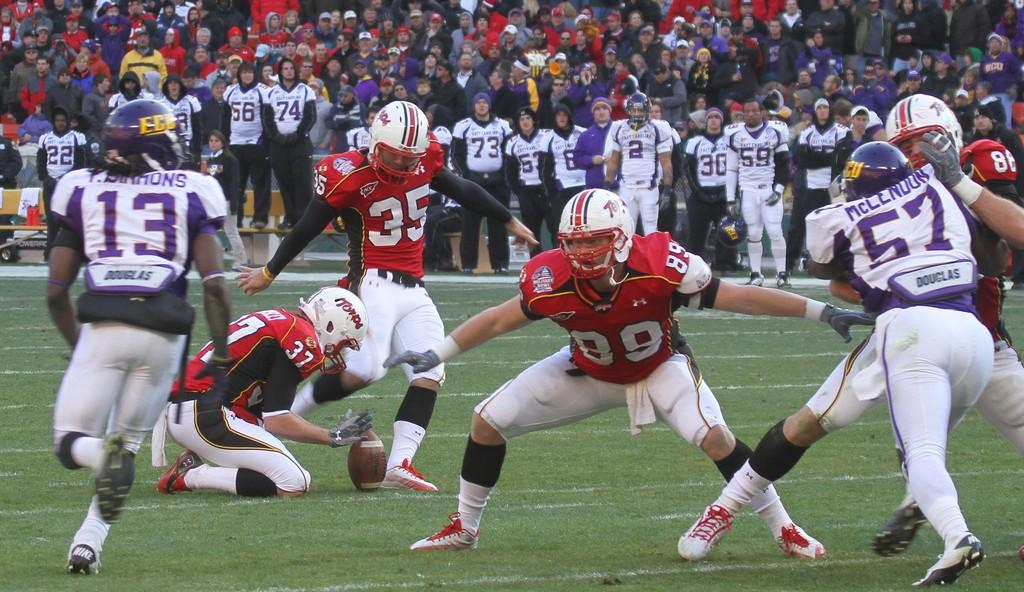What activity is taking place in the image? There are players playing on a ground. What can be seen in the background of the image? In the background, there are people standing and people sitting on chairs. What type of horn can be heard in the image? There is no horn present in the image, and therefore no sound can be heard. 